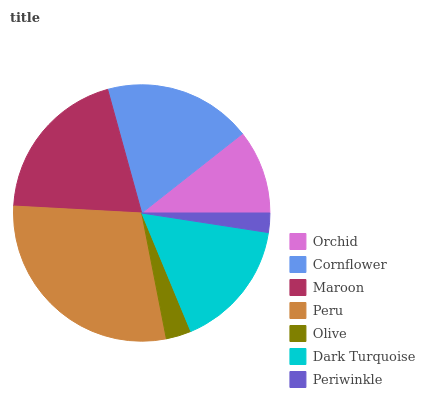Is Periwinkle the minimum?
Answer yes or no. Yes. Is Peru the maximum?
Answer yes or no. Yes. Is Cornflower the minimum?
Answer yes or no. No. Is Cornflower the maximum?
Answer yes or no. No. Is Cornflower greater than Orchid?
Answer yes or no. Yes. Is Orchid less than Cornflower?
Answer yes or no. Yes. Is Orchid greater than Cornflower?
Answer yes or no. No. Is Cornflower less than Orchid?
Answer yes or no. No. Is Dark Turquoise the high median?
Answer yes or no. Yes. Is Dark Turquoise the low median?
Answer yes or no. Yes. Is Periwinkle the high median?
Answer yes or no. No. Is Orchid the low median?
Answer yes or no. No. 